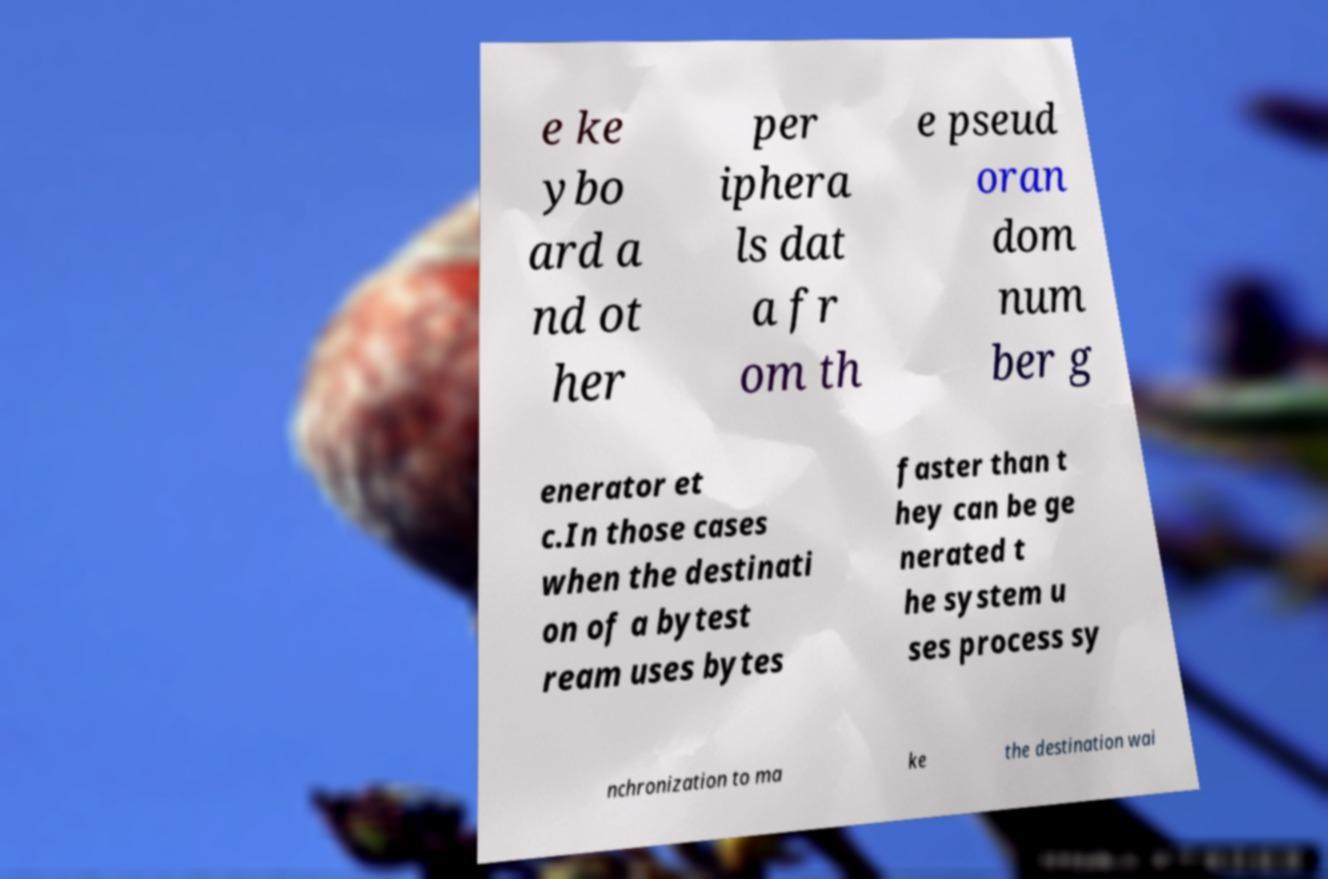What messages or text are displayed in this image? I need them in a readable, typed format. e ke ybo ard a nd ot her per iphera ls dat a fr om th e pseud oran dom num ber g enerator et c.In those cases when the destinati on of a bytest ream uses bytes faster than t hey can be ge nerated t he system u ses process sy nchronization to ma ke the destination wai 